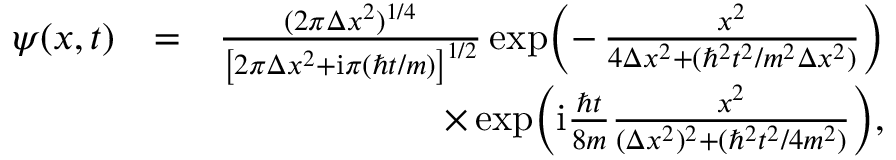Convert formula to latex. <formula><loc_0><loc_0><loc_500><loc_500>\begin{array} { r l r } { \psi ( x , t ) } & { = } & { \frac { ( 2 \pi \Delta x ^ { 2 } ) ^ { 1 / 4 } } { \left [ 2 \pi \Delta x ^ { 2 } + i \pi ( \hbar { t } / m ) \right ] ^ { 1 / 2 } } \exp \, \left ( - \, \frac { x ^ { 2 } } { 4 \Delta x ^ { 2 } + ( \hbar { ^ } { 2 } t ^ { 2 } / m ^ { 2 } \Delta x ^ { 2 } ) } \right ) } \\ & { \times \exp \, \left ( i \frac { \hbar { t } } { 8 m } \frac { x ^ { 2 } } { ( \Delta x ^ { 2 } ) ^ { 2 } + ( \hbar { ^ } { 2 } t ^ { 2 } / 4 m ^ { 2 } ) } \right ) \, , } \end{array}</formula> 